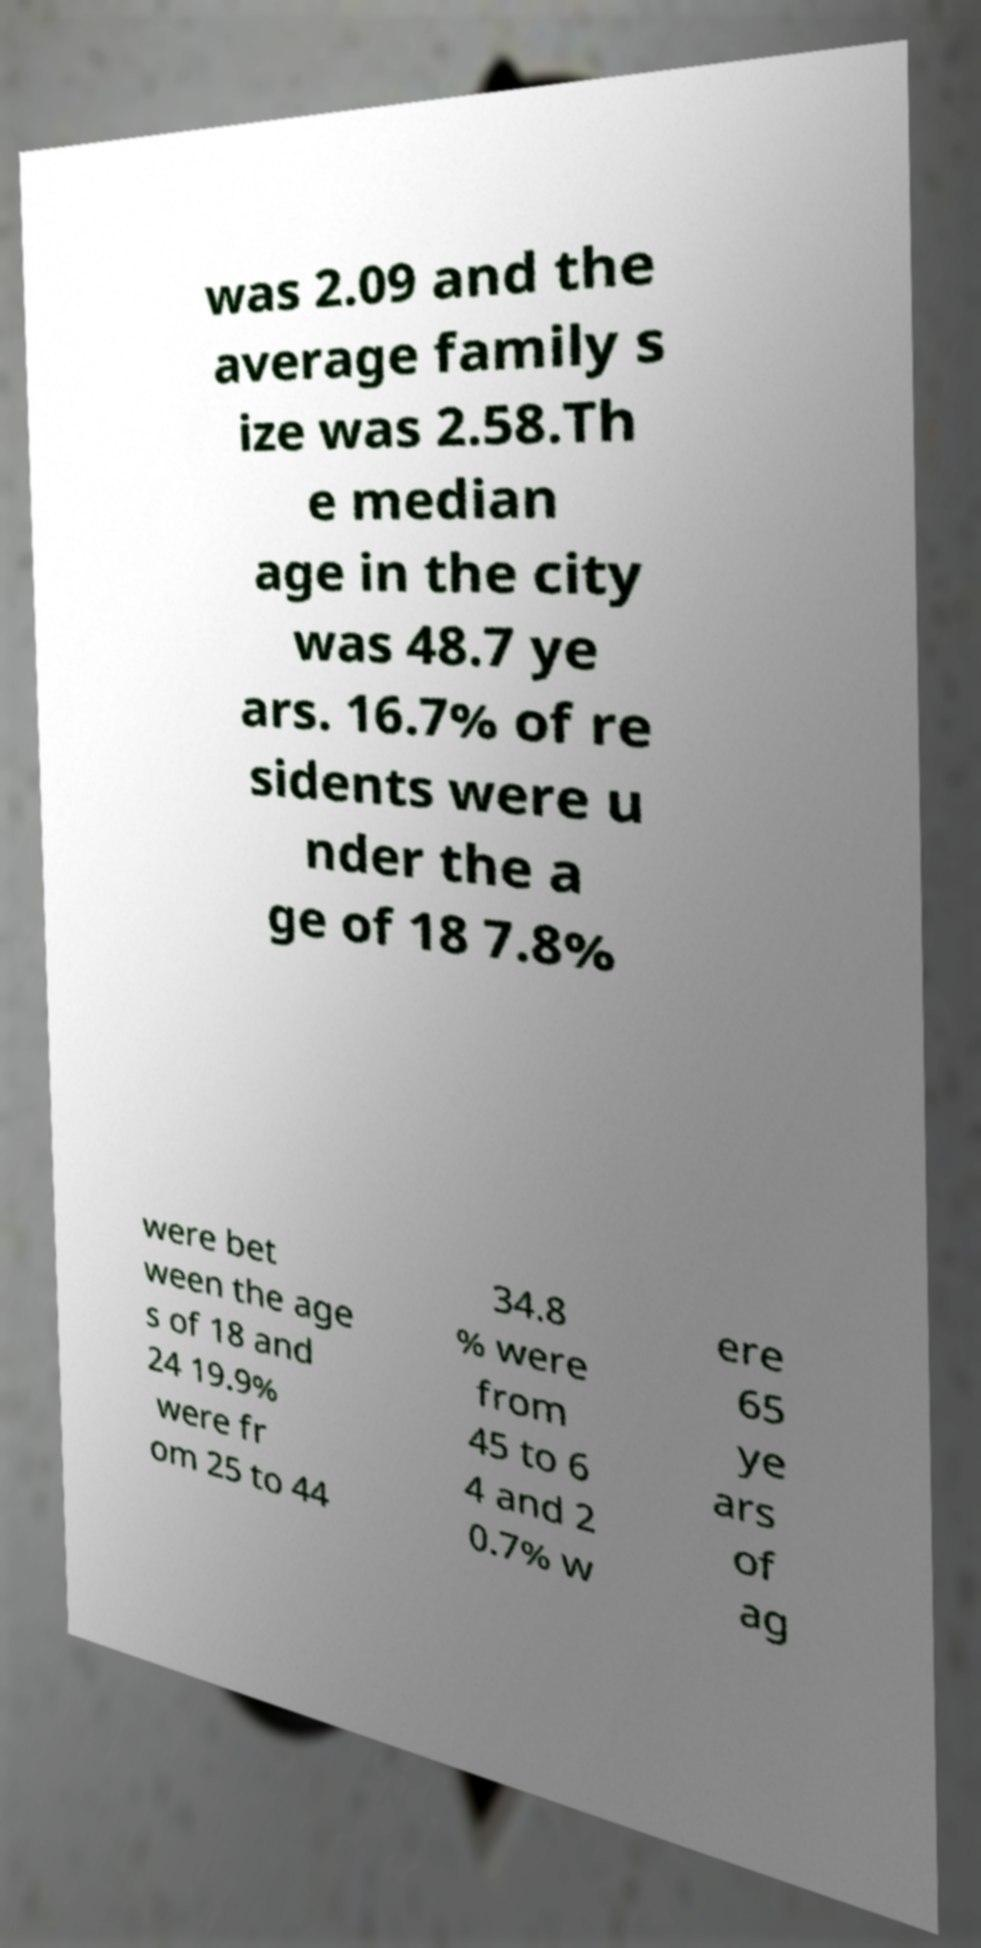There's text embedded in this image that I need extracted. Can you transcribe it verbatim? was 2.09 and the average family s ize was 2.58.Th e median age in the city was 48.7 ye ars. 16.7% of re sidents were u nder the a ge of 18 7.8% were bet ween the age s of 18 and 24 19.9% were fr om 25 to 44 34.8 % were from 45 to 6 4 and 2 0.7% w ere 65 ye ars of ag 